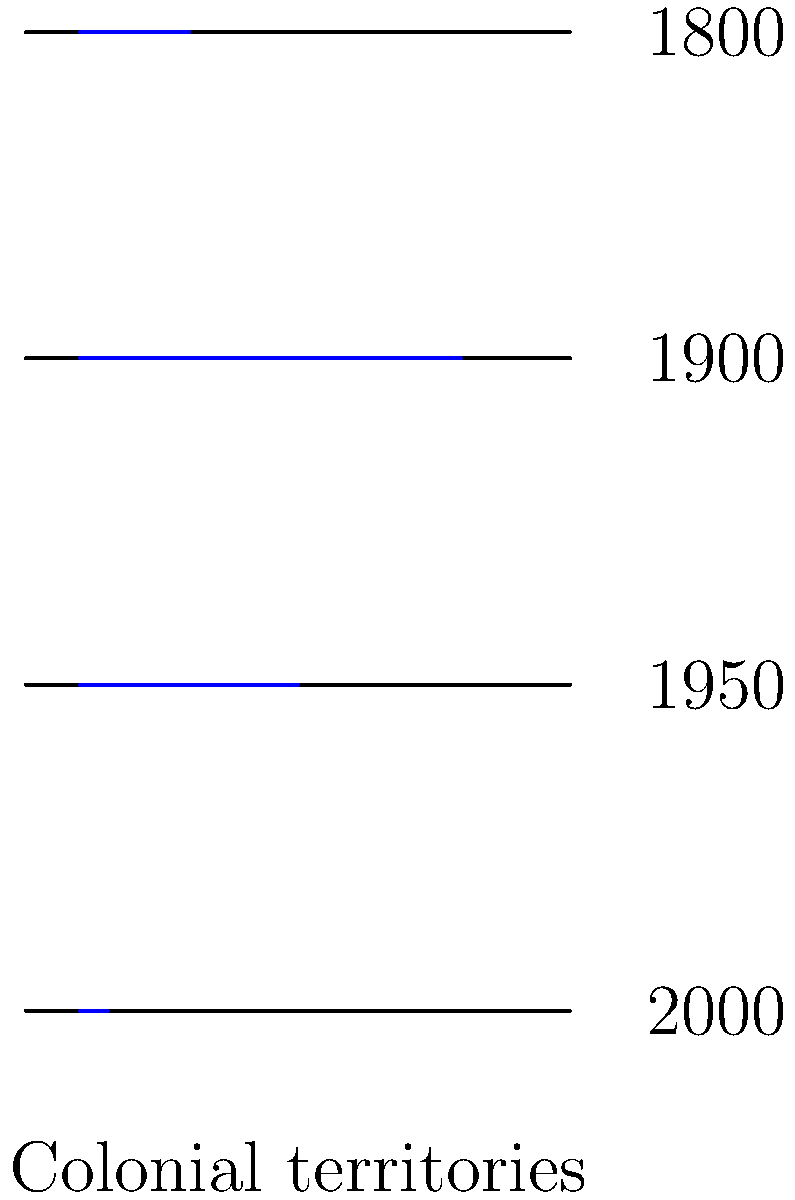Analyze the change in global colonial territories from 1800 to 2000 as depicted in the series of world maps. What trend does this visualization reveal about the extent of colonial control over time, and how does this relate to the broader narrative of decolonization in the 20th century? To analyze the change in global colonial territories from 1800 to 2000, we need to examine the blue lines representing colonial territories in each time period:

1. 1800: The colonial territory is relatively small, indicating limited colonial control.

2. 1900: There is a significant increase in colonial territory, representing the peak of European imperialism and the "Scramble for Africa."

3. 1950: The colonial territory has decreased noticeably, reflecting the beginning of decolonization processes after World War II.

4. 2000: Colonial territory has shrunk dramatically, indicating the near-completion of decolonization.

This visualization reveals a clear trend of initial expansion followed by contraction of colonial territories:

1. Expansion phase (1800-1900): Rapid growth of colonial empires, driven by European powers.

2. Peak colonialism (around 1900): Maximum extent of global colonial control.

3. Decolonization phase (1900-2000): Gradual, then accelerated, reduction in colonial territories.

This trend relates to the broader narrative of decolonization in the 20th century:

1. Post-World War II era: Many colonies gained independence, particularly in Asia and Africa.

2. UN Charter and global politics: Support for self-determination and anti-colonial movements increased.

3. Cold War dynamics: Superpower competition influenced decolonization processes.

4. Economic and political shifts: Changes in global power structures and economic systems affected colonial relationships.

The visualization thus illustrates the rise and fall of colonial empires, reflecting the complex historical processes of imperialism, nationalism, and global power dynamics throughout the 19th and 20th centuries.
Answer: Expansion of colonial territories from 1800 to 1900, followed by rapid contraction from 1900 to 2000, illustrating the rise and fall of colonial empires and the process of 20th-century decolonization. 